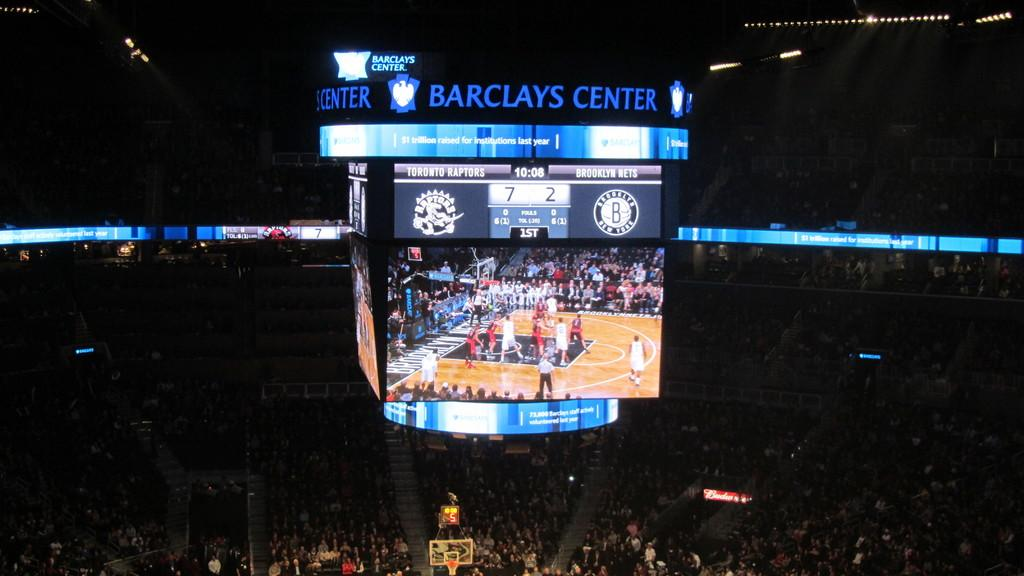<image>
Present a compact description of the photo's key features. A screen shows the action on the basketball court of the Barclays Center. 